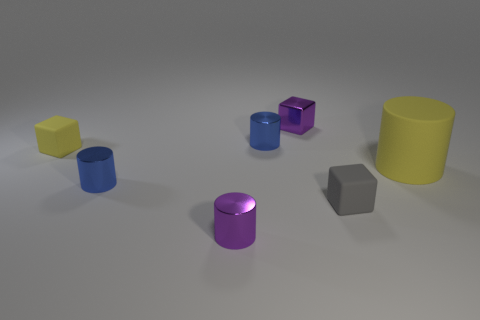Subtract all tiny gray blocks. How many blocks are left? 2 Subtract all red spheres. How many blue cylinders are left? 2 Subtract 1 cubes. How many cubes are left? 2 Subtract all blue cylinders. How many cylinders are left? 2 Add 1 tiny green cylinders. How many objects exist? 8 Subtract all cylinders. How many objects are left? 3 Add 5 blue metallic things. How many blue metallic things are left? 7 Add 3 rubber cylinders. How many rubber cylinders exist? 4 Subtract 0 cyan blocks. How many objects are left? 7 Subtract all yellow cylinders. Subtract all blue blocks. How many cylinders are left? 3 